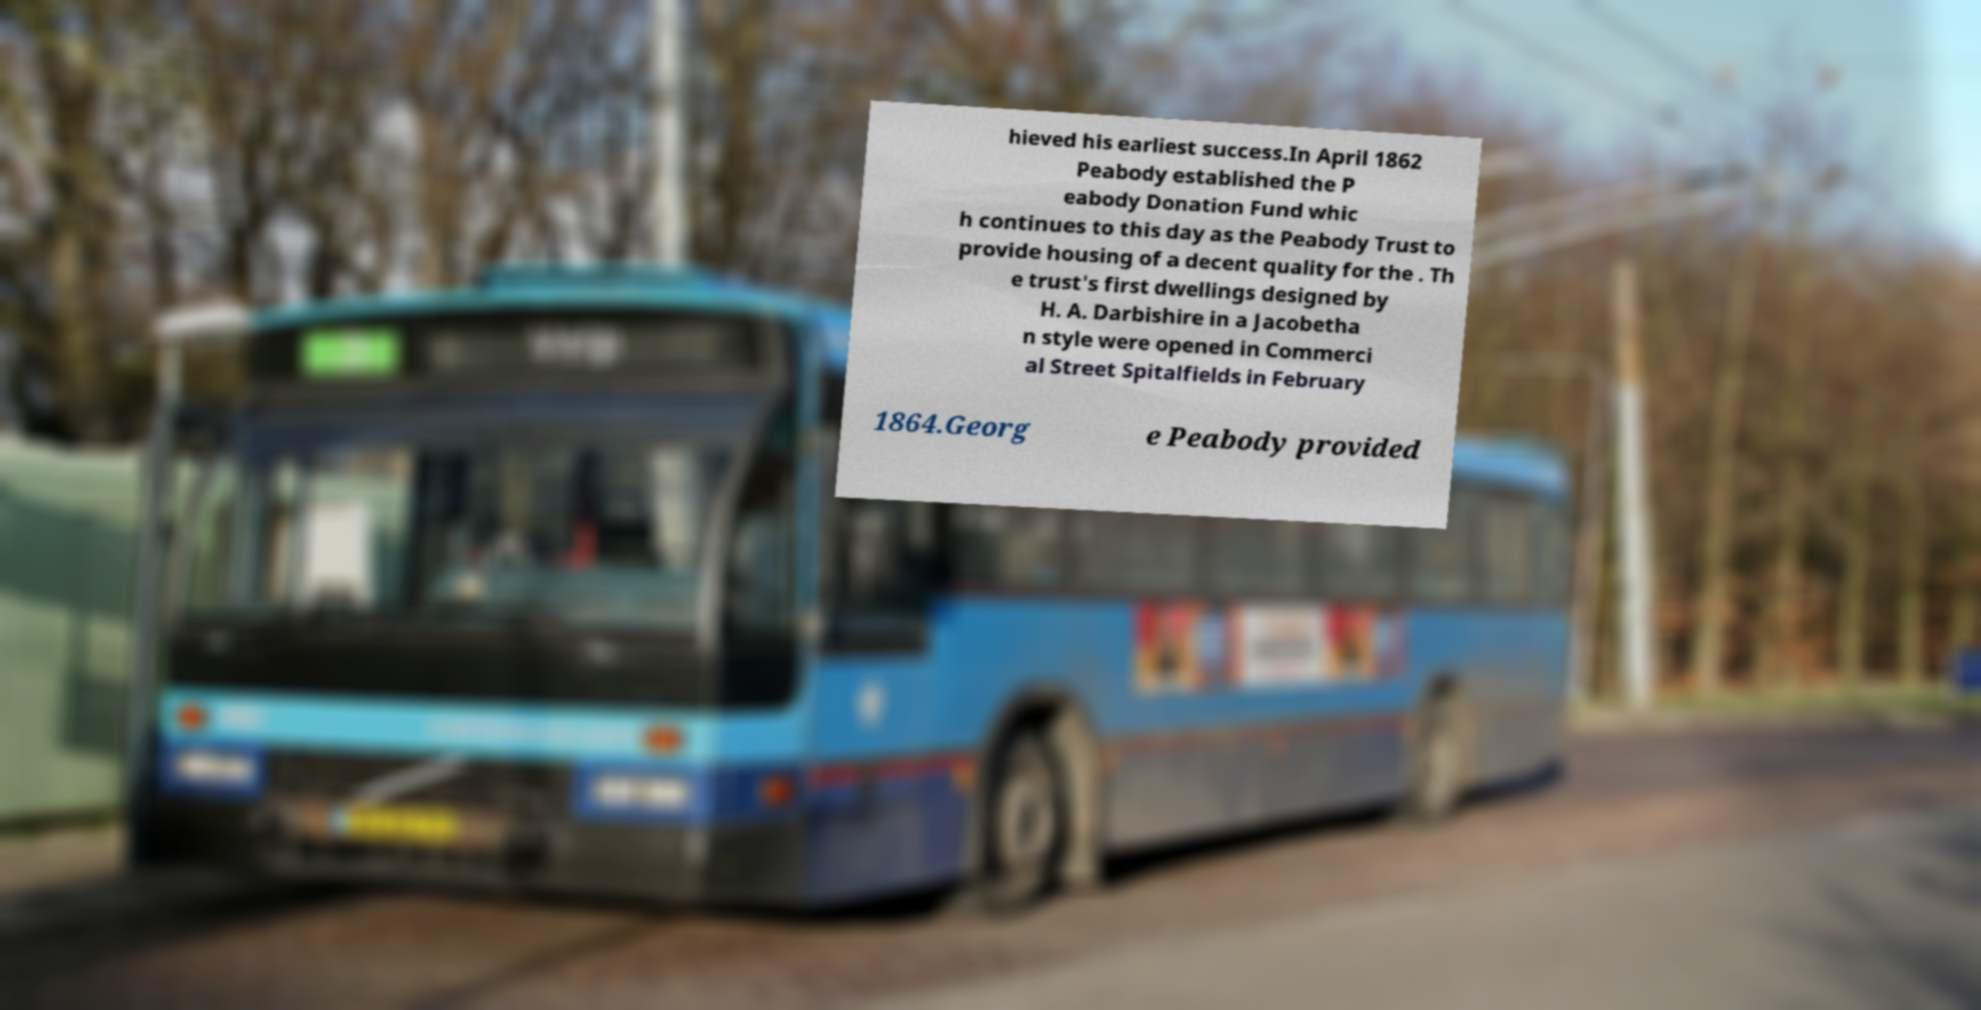Could you assist in decoding the text presented in this image and type it out clearly? hieved his earliest success.In April 1862 Peabody established the P eabody Donation Fund whic h continues to this day as the Peabody Trust to provide housing of a decent quality for the . Th e trust's first dwellings designed by H. A. Darbishire in a Jacobetha n style were opened in Commerci al Street Spitalfields in February 1864.Georg e Peabody provided 